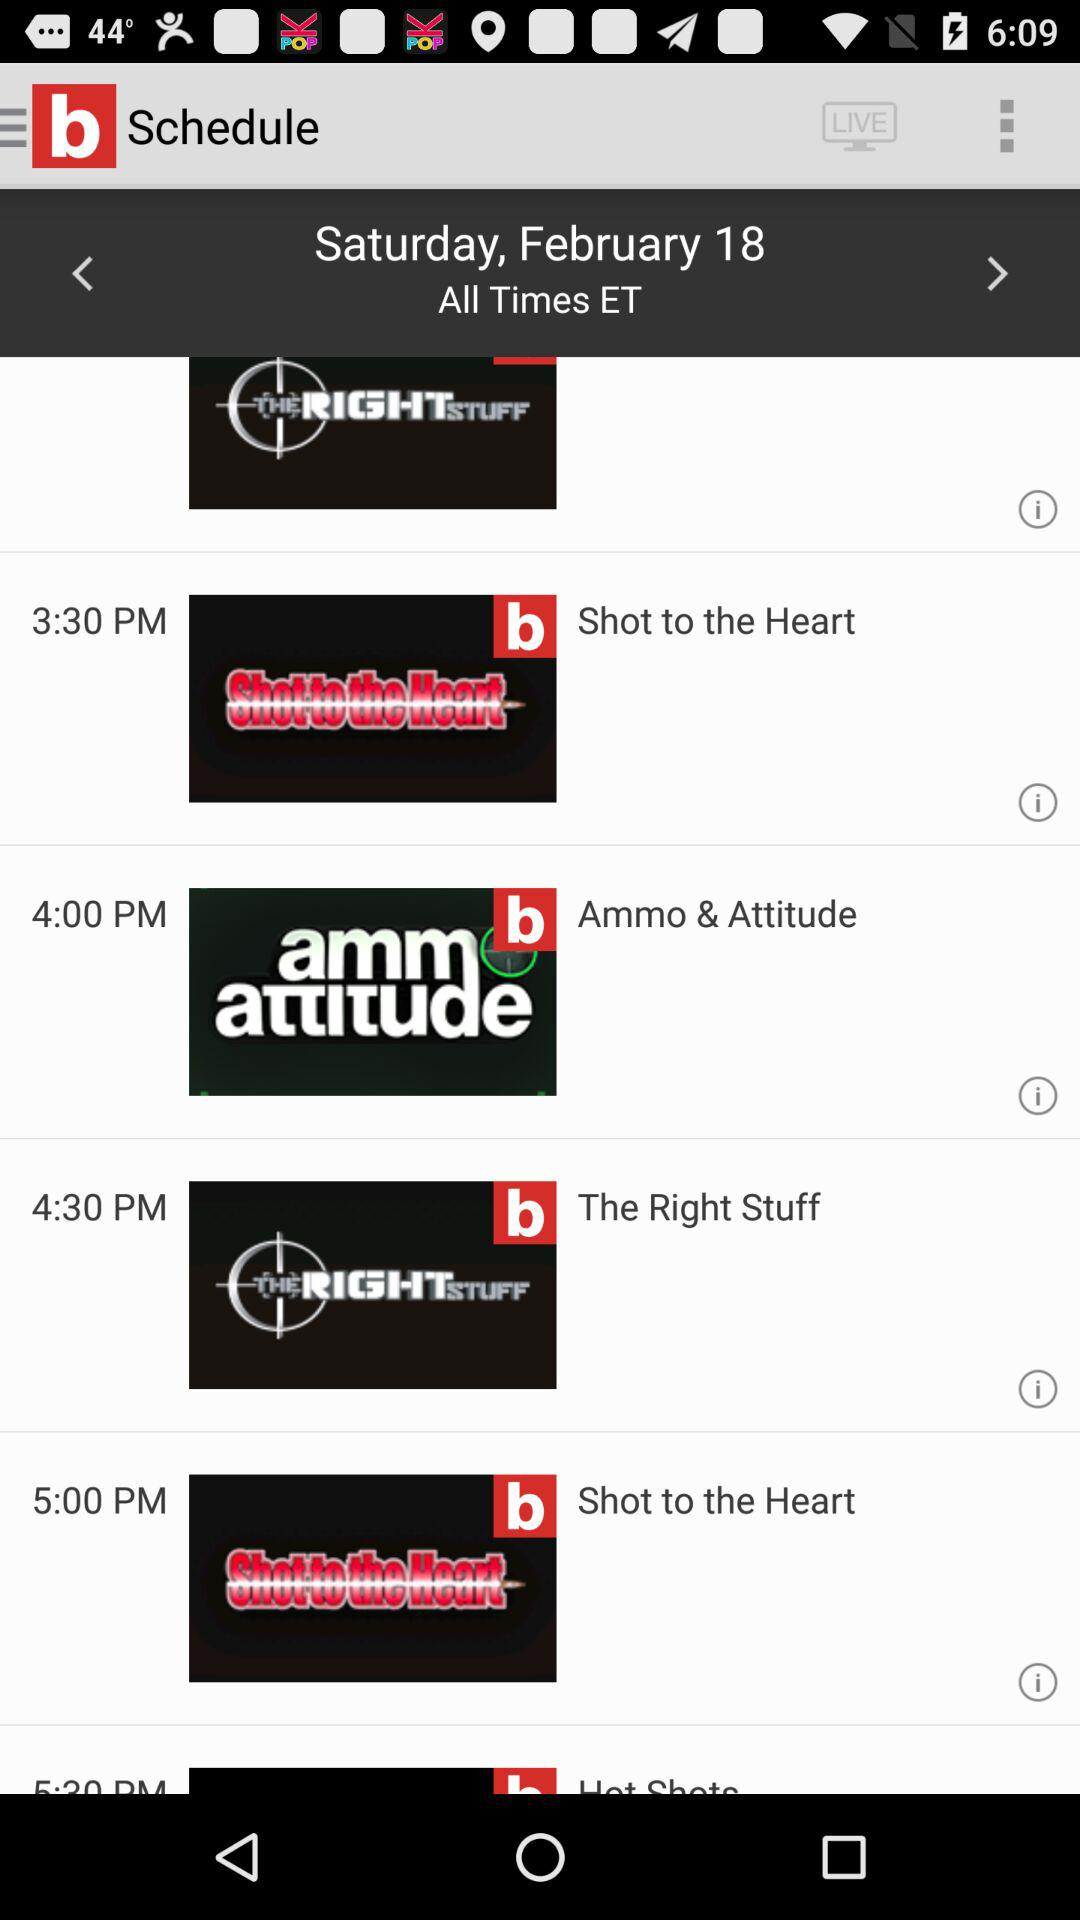Which show comes after "The Right Stuff" at 5:00 p.m.? The show is "Shot to the Heart". 